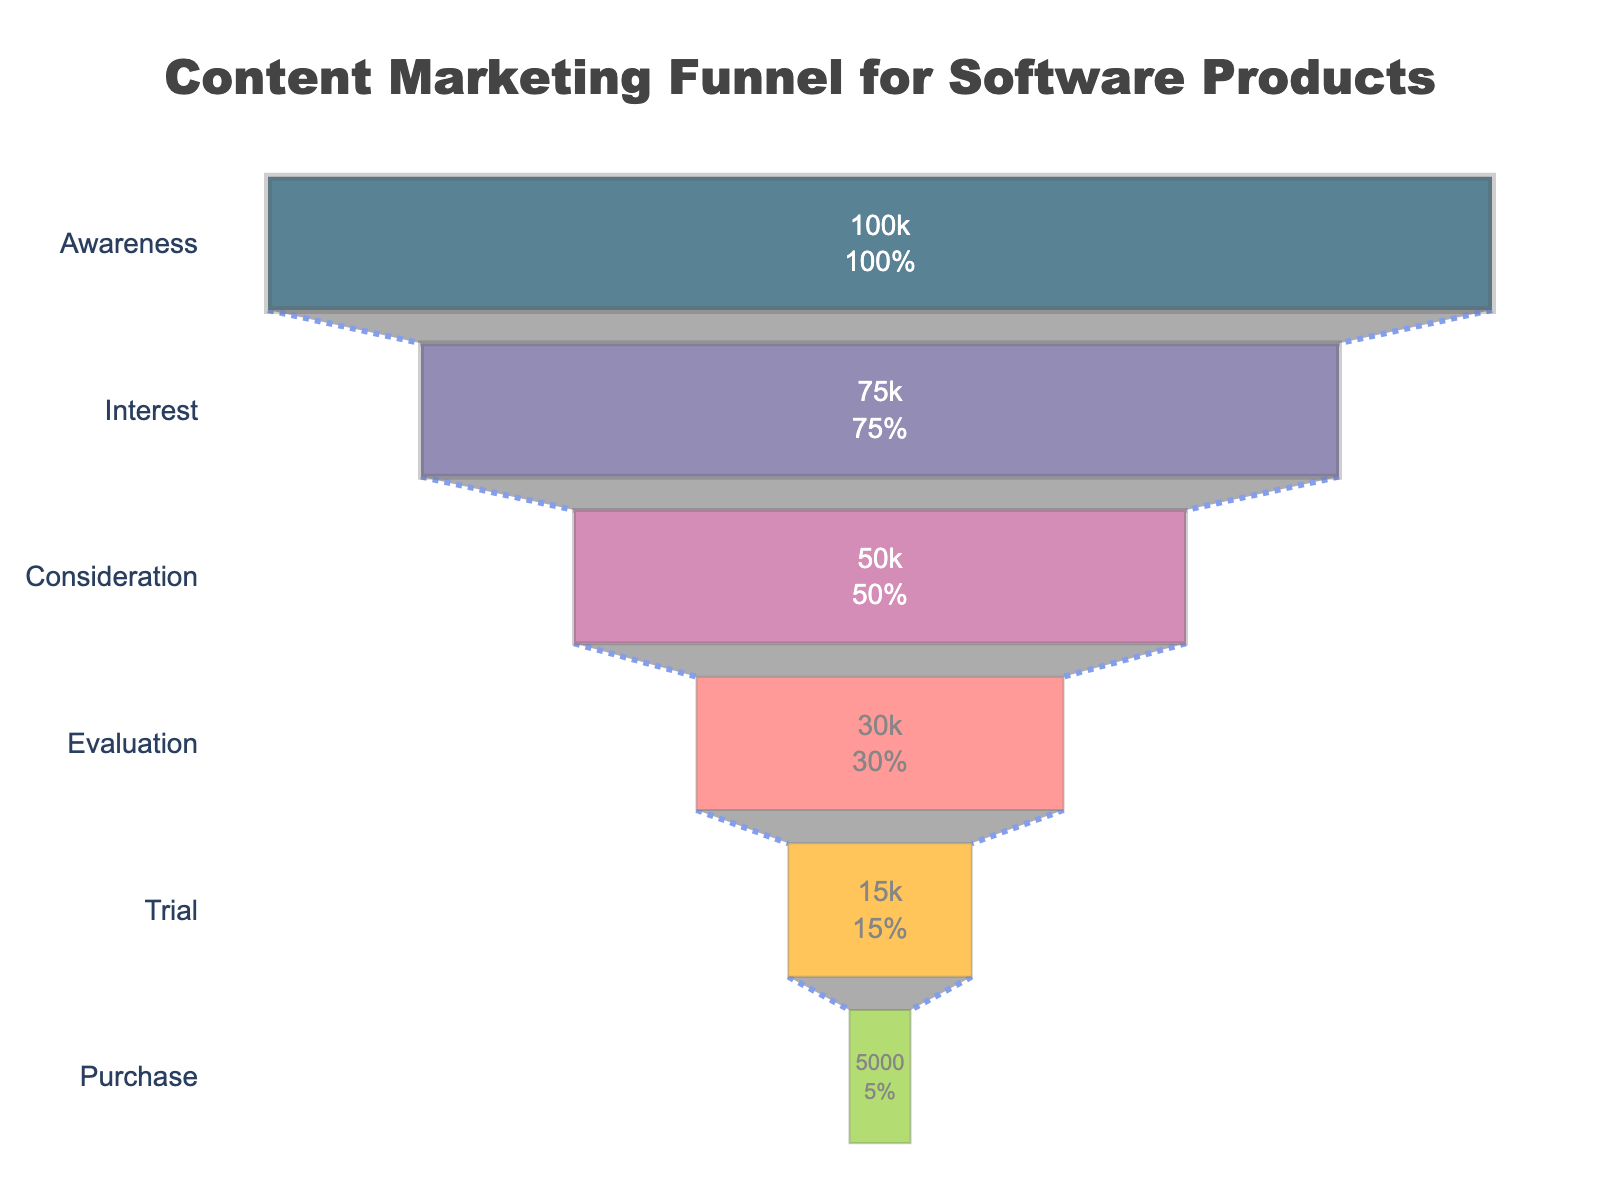What is the title of the funnel chart? The title can be found at the top of the chart. It reads "Content Marketing Funnel for Software Products".
Answer: Content Marketing Funnel for Software Products How many users are in the Awareness stage? The number of users at each stage is displayed inside the funnel segment. The Awareness stage shows 100,000 users.
Answer: 100,000 Which stage has the lowest number of users? Identify the smallest number in the dataset. The Purchase stage has the lowest number of users, which is 5,000.
Answer: Purchase How many stages are represented in the funnel chart? Count the unique stages displayed along the vertical axis of the funnel. There are six stages: Awareness, Interest, Consideration, Evaluation, Trial, and Purchase.
Answer: 6 What percentage of users move from Awareness to Interest? Locate the percentage displayed inside the Interest segment of the funnel. It shows the value and percentage of the initial step. The percentage is 75%.
Answer: 75% What is the total difference in the number of users from Awareness to Purchase? Subtract the number of users in the Purchase stage from the number of users in the Awareness stage: 100,000 (Awareness) - 5,000 (Purchase) = 95,000.
Answer: 95,000 By how many users do the numbers decrease from the Consideration to the Evaluation stage? Subtract the number of users in the Evaluation stage from the number of users in the Consideration stage: 50,000 (Consideration) - 30,000 (Evaluation) = 20,000.
Answer: 20,000 What is the average number of users from Evaluation to Purchase? Calculate the average by summing the users in each stage from Evaluation to Purchase, then dividing by the number of stages: (30,000 + 15,000 + 5,000) / 3 = 50,000 / 3 ≈ 16,667.
Answer: 16,667 What percentage of users in the Trial stage move to the Purchase stage? Locate the percentage displayed inside the Purchase segment of the funnel. It shows the percentage as 33% of users who were in the Trial stage.
Answer: 33% 